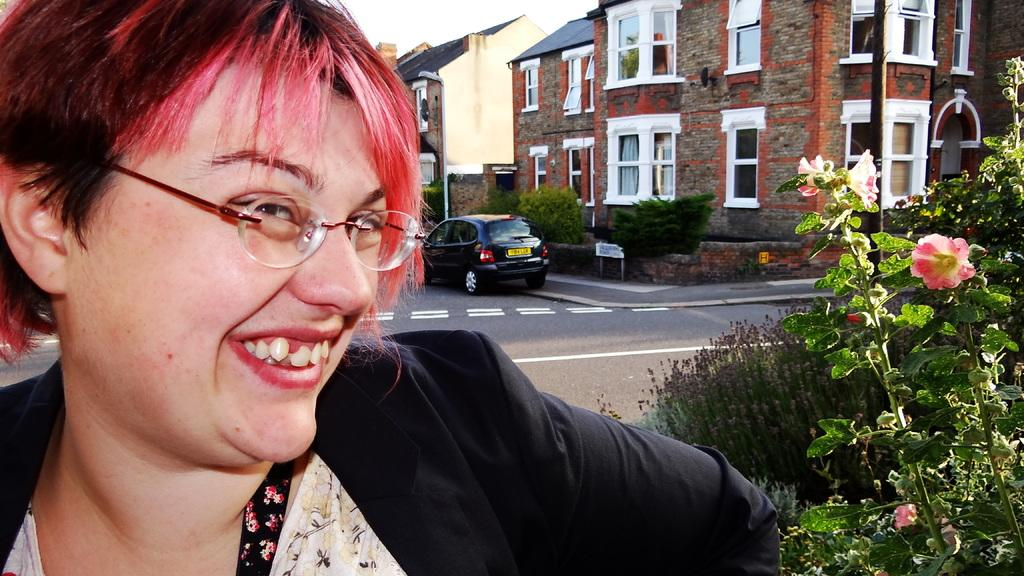Who is present in the image? There is a woman in the image. What is the woman doing in the image? The woman is smiling in the image. What is the woman wearing in the image? The woman is wearing spectacles in the image. What can be seen on the road in the image? There is a car on the road in the image. What type of vegetation is present in the image? There are plants and flowers in the image. What man-made structures can be seen in the image? There are boards, poles, and buildings in the image. What type of drum can be heard playing in the image? There is no drum present in the image, and therefore no sound can be heard. 